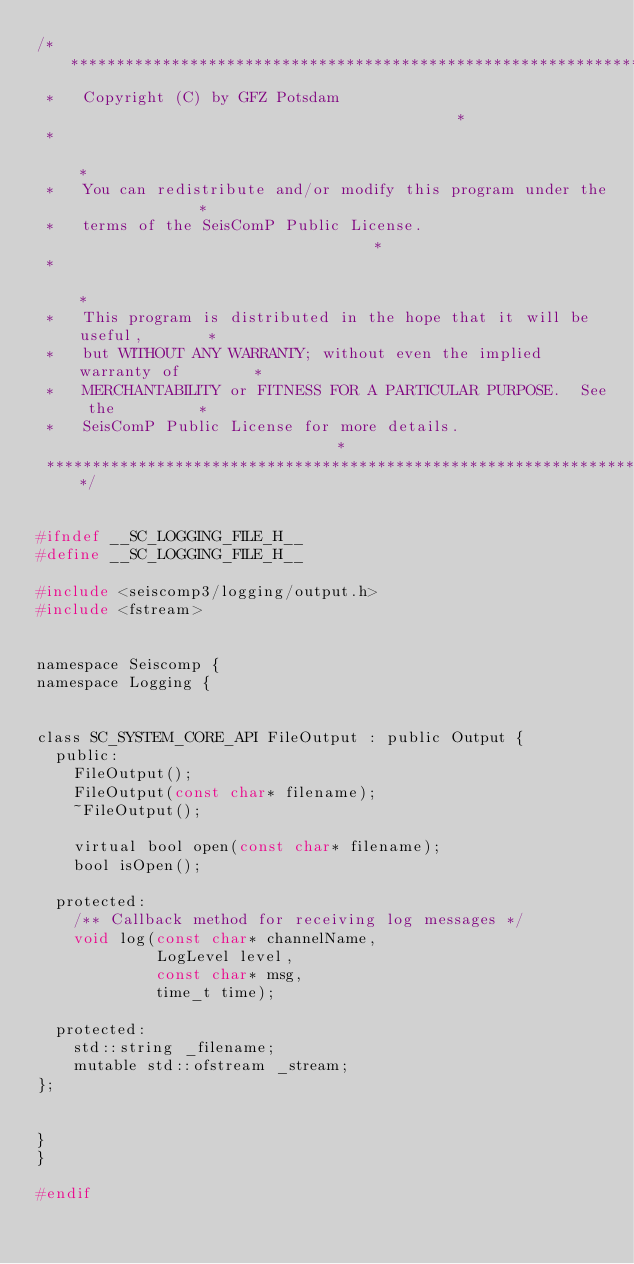Convert code to text. <code><loc_0><loc_0><loc_500><loc_500><_C_>/***************************************************************************
 *   Copyright (C) by GFZ Potsdam                                          *
 *                                                                         *
 *   You can redistribute and/or modify this program under the             *
 *   terms of the SeisComP Public License.                                 *
 *                                                                         *
 *   This program is distributed in the hope that it will be useful,       *
 *   but WITHOUT ANY WARRANTY; without even the implied warranty of        *
 *   MERCHANTABILITY or FITNESS FOR A PARTICULAR PURPOSE.  See the         *
 *   SeisComP Public License for more details.                             *
 ***************************************************************************/


#ifndef __SC_LOGGING_FILE_H__
#define __SC_LOGGING_FILE_H__

#include <seiscomp3/logging/output.h>
#include <fstream>


namespace Seiscomp {
namespace Logging {


class SC_SYSTEM_CORE_API FileOutput : public Output {
	public:
		FileOutput();
		FileOutput(const char* filename);
		~FileOutput();

		virtual bool open(const char* filename);
		bool isOpen();

	protected:
		/** Callback method for receiving log messages */
		void log(const char* channelName,
		         LogLevel level,
		         const char* msg,
		         time_t time);

	protected:
		std::string _filename;
		mutable std::ofstream _stream;
};


}
}

#endif
</code> 